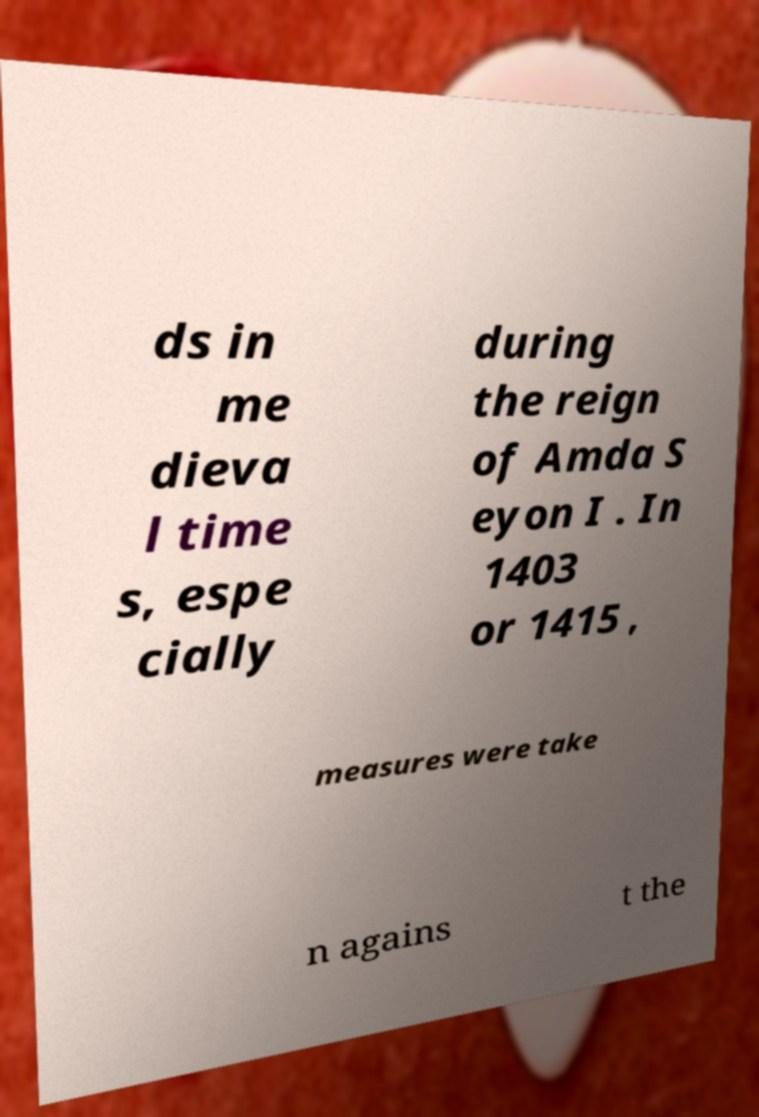Can you accurately transcribe the text from the provided image for me? ds in me dieva l time s, espe cially during the reign of Amda S eyon I . In 1403 or 1415 , measures were take n agains t the 